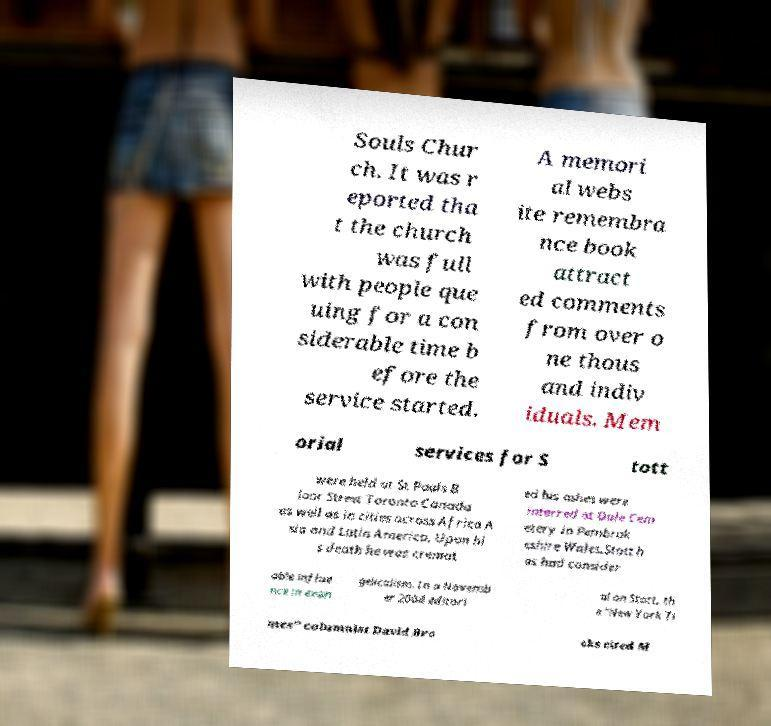Can you accurately transcribe the text from the provided image for me? Souls Chur ch. It was r eported tha t the church was full with people que uing for a con siderable time b efore the service started. A memori al webs ite remembra nce book attract ed comments from over o ne thous and indiv iduals. Mem orial services for S tott were held at St Pauls B loor Street Toronto Canada as well as in cities across Africa A sia and Latin America. Upon hi s death he was cremat ed his ashes were interred at Dale Cem etery in Pembrok eshire Wales.Stott h as had consider able influe nce in evan gelicalism. In a Novemb er 2004 editori al on Stott, th e "New York Ti mes" columnist David Bro oks cited M 